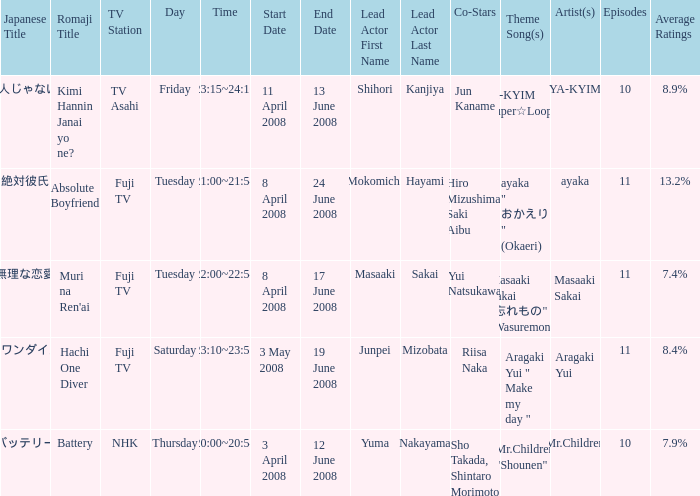What are the romaji title(s) with the theme song "ya-kyim "super☆looper"? Kimi Hannin Janai yo ne?. 